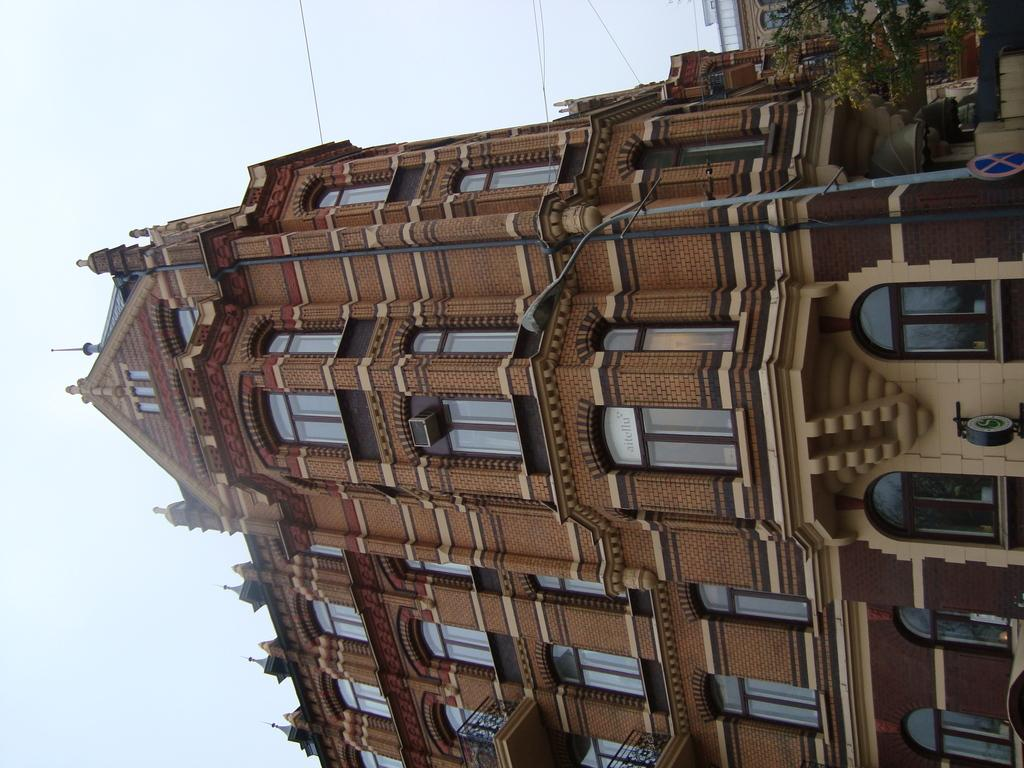What is the main structure visible in the image? There is a building in the image. What feature can be seen on the building? The building has windows. What is the condition of the sky in the image? The sky is clear in the image. What type of notebook is being used by the person in the image? There is no person present in the image, and therefore no notebook can be observed. What color is the toothpaste on the windowsill in the image? There is no toothpaste present in the image. 